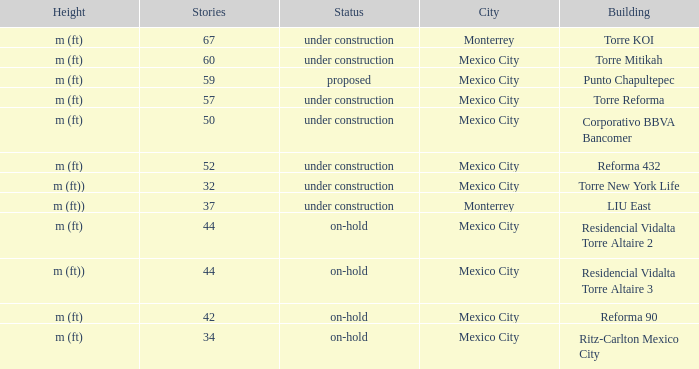What is the status of the torre reforma building that is over 44 stories in mexico city? Under construction. 